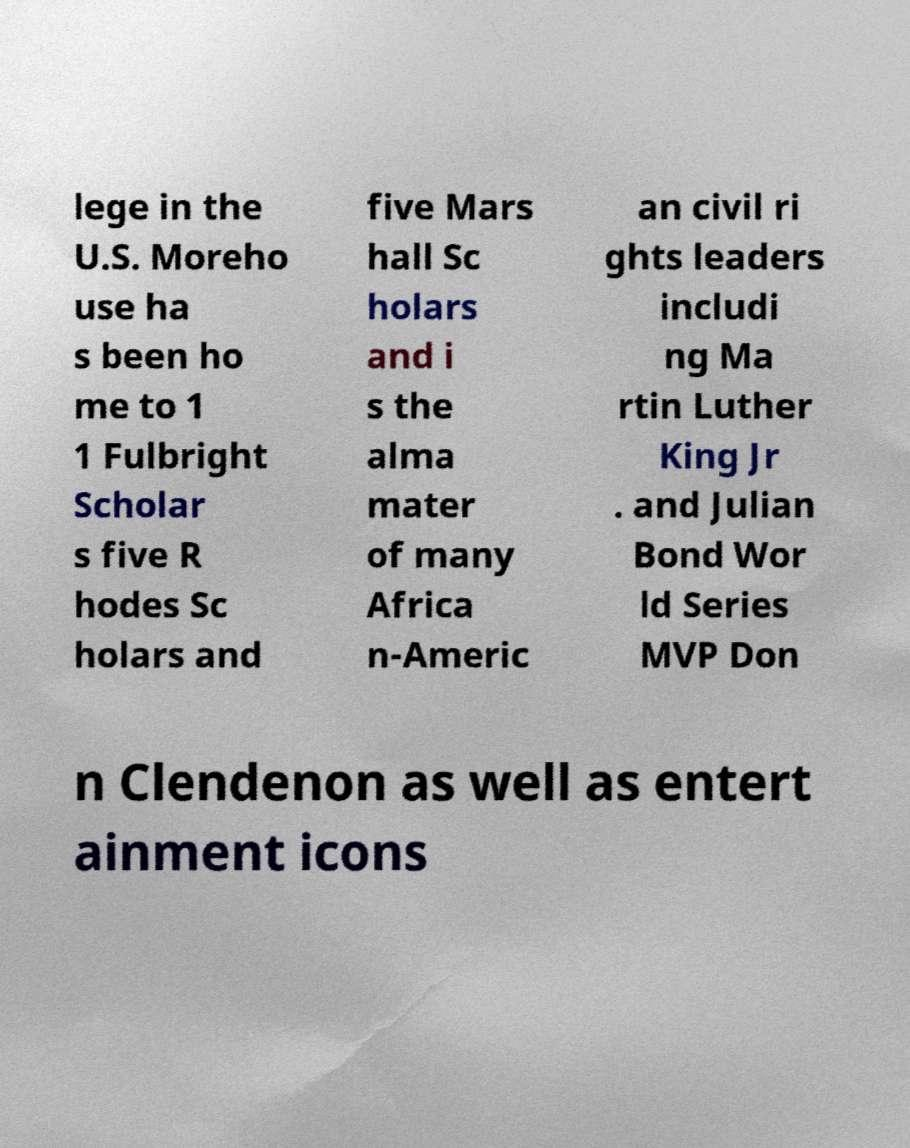For documentation purposes, I need the text within this image transcribed. Could you provide that? lege in the U.S. Moreho use ha s been ho me to 1 1 Fulbright Scholar s five R hodes Sc holars and five Mars hall Sc holars and i s the alma mater of many Africa n-Americ an civil ri ghts leaders includi ng Ma rtin Luther King Jr . and Julian Bond Wor ld Series MVP Don n Clendenon as well as entert ainment icons 